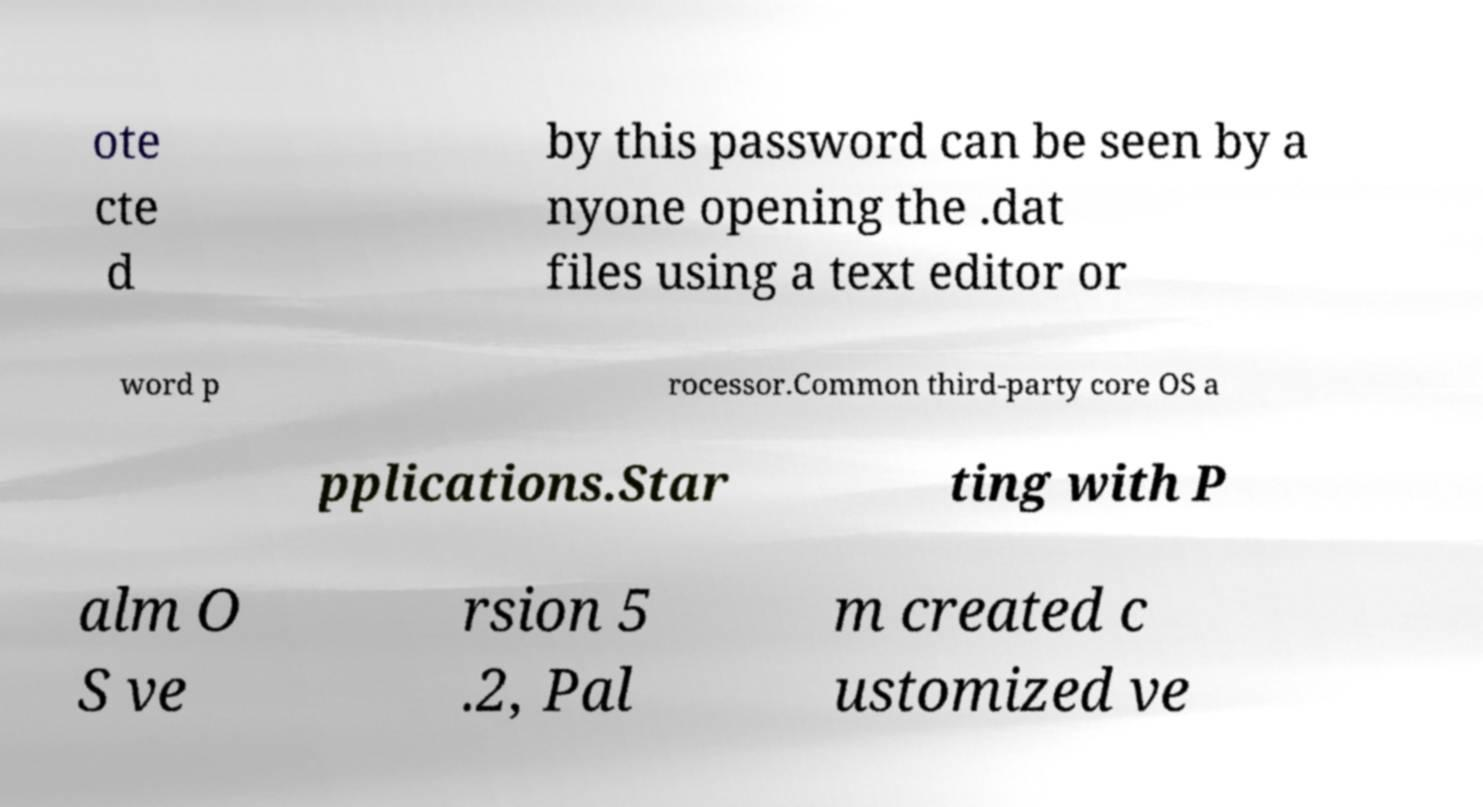Could you extract and type out the text from this image? ote cte d by this password can be seen by a nyone opening the .dat files using a text editor or word p rocessor.Common third-party core OS a pplications.Star ting with P alm O S ve rsion 5 .2, Pal m created c ustomized ve 